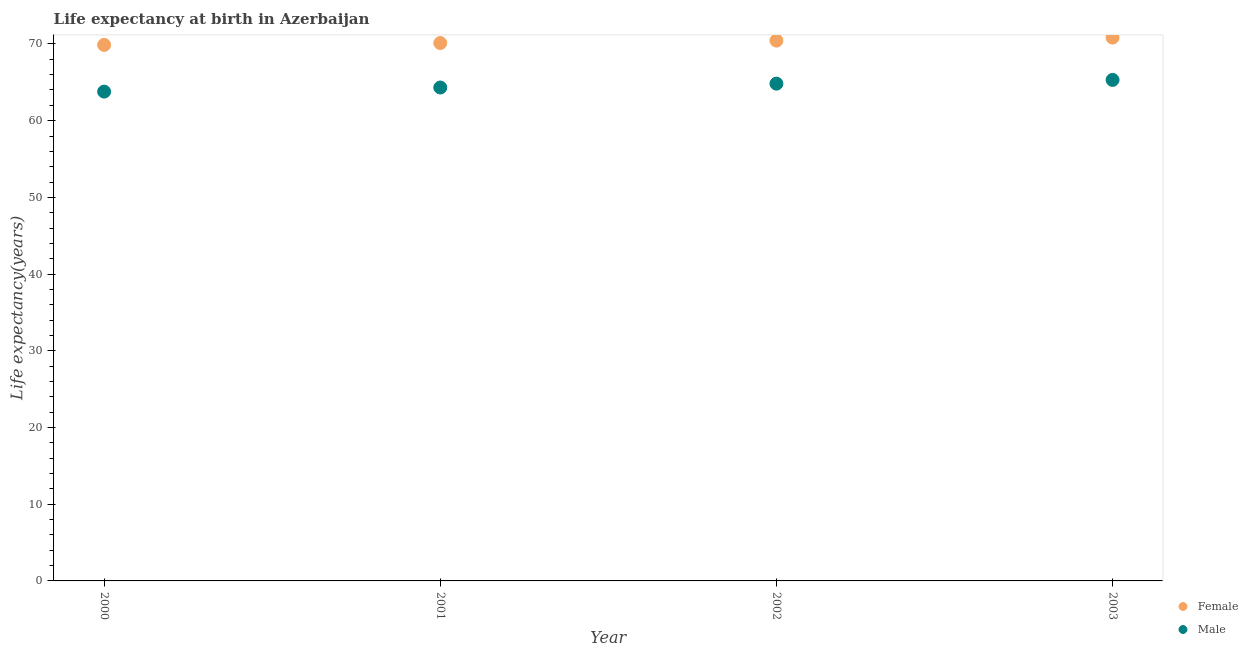What is the life expectancy(male) in 2001?
Ensure brevity in your answer.  64.32. Across all years, what is the maximum life expectancy(male)?
Provide a short and direct response. 65.31. Across all years, what is the minimum life expectancy(female)?
Offer a terse response. 69.88. In which year was the life expectancy(male) minimum?
Your response must be concise. 2000. What is the total life expectancy(female) in the graph?
Offer a terse response. 281.26. What is the difference between the life expectancy(female) in 2002 and that in 2003?
Keep it short and to the point. -0.4. What is the difference between the life expectancy(female) in 2003 and the life expectancy(male) in 2000?
Your answer should be compact. 7.04. What is the average life expectancy(female) per year?
Provide a succinct answer. 70.32. In the year 2003, what is the difference between the life expectancy(male) and life expectancy(female)?
Provide a succinct answer. -5.52. What is the ratio of the life expectancy(female) in 2001 to that in 2002?
Make the answer very short. 1. Is the difference between the life expectancy(female) in 2001 and 2002 greater than the difference between the life expectancy(male) in 2001 and 2002?
Make the answer very short. Yes. What is the difference between the highest and the second highest life expectancy(female)?
Provide a succinct answer. 0.4. What is the difference between the highest and the lowest life expectancy(male)?
Offer a terse response. 1.52. Is the sum of the life expectancy(female) in 2000 and 2002 greater than the maximum life expectancy(male) across all years?
Make the answer very short. Yes. Does the life expectancy(male) monotonically increase over the years?
Your response must be concise. Yes. How many dotlines are there?
Make the answer very short. 2. How many years are there in the graph?
Offer a terse response. 4. What is the difference between two consecutive major ticks on the Y-axis?
Your answer should be very brief. 10. Are the values on the major ticks of Y-axis written in scientific E-notation?
Provide a short and direct response. No. Does the graph contain grids?
Your response must be concise. No. Where does the legend appear in the graph?
Make the answer very short. Bottom right. How many legend labels are there?
Offer a terse response. 2. How are the legend labels stacked?
Make the answer very short. Vertical. What is the title of the graph?
Your response must be concise. Life expectancy at birth in Azerbaijan. What is the label or title of the Y-axis?
Give a very brief answer. Life expectancy(years). What is the Life expectancy(years) of Female in 2000?
Your answer should be compact. 69.88. What is the Life expectancy(years) in Male in 2000?
Keep it short and to the point. 63.79. What is the Life expectancy(years) of Female in 2001?
Offer a terse response. 70.12. What is the Life expectancy(years) in Male in 2001?
Your response must be concise. 64.32. What is the Life expectancy(years) in Female in 2002?
Your answer should be very brief. 70.44. What is the Life expectancy(years) in Male in 2002?
Give a very brief answer. 64.82. What is the Life expectancy(years) of Female in 2003?
Offer a very short reply. 70.83. What is the Life expectancy(years) of Male in 2003?
Offer a terse response. 65.31. Across all years, what is the maximum Life expectancy(years) in Female?
Your answer should be compact. 70.83. Across all years, what is the maximum Life expectancy(years) in Male?
Your answer should be very brief. 65.31. Across all years, what is the minimum Life expectancy(years) in Female?
Offer a very short reply. 69.88. Across all years, what is the minimum Life expectancy(years) in Male?
Give a very brief answer. 63.79. What is the total Life expectancy(years) of Female in the graph?
Your answer should be very brief. 281.26. What is the total Life expectancy(years) of Male in the graph?
Make the answer very short. 258.25. What is the difference between the Life expectancy(years) of Female in 2000 and that in 2001?
Offer a terse response. -0.24. What is the difference between the Life expectancy(years) in Male in 2000 and that in 2001?
Offer a terse response. -0.53. What is the difference between the Life expectancy(years) of Female in 2000 and that in 2002?
Your answer should be very brief. -0.56. What is the difference between the Life expectancy(years) of Male in 2000 and that in 2002?
Your answer should be compact. -1.04. What is the difference between the Life expectancy(years) in Female in 2000 and that in 2003?
Give a very brief answer. -0.95. What is the difference between the Life expectancy(years) of Male in 2000 and that in 2003?
Your answer should be very brief. -1.52. What is the difference between the Life expectancy(years) in Female in 2001 and that in 2002?
Ensure brevity in your answer.  -0.32. What is the difference between the Life expectancy(years) of Male in 2001 and that in 2002?
Keep it short and to the point. -0.5. What is the difference between the Life expectancy(years) of Female in 2001 and that in 2003?
Give a very brief answer. -0.71. What is the difference between the Life expectancy(years) of Male in 2001 and that in 2003?
Make the answer very short. -0.99. What is the difference between the Life expectancy(years) in Female in 2002 and that in 2003?
Your answer should be very brief. -0.4. What is the difference between the Life expectancy(years) in Male in 2002 and that in 2003?
Make the answer very short. -0.49. What is the difference between the Life expectancy(years) of Female in 2000 and the Life expectancy(years) of Male in 2001?
Provide a succinct answer. 5.55. What is the difference between the Life expectancy(years) in Female in 2000 and the Life expectancy(years) in Male in 2002?
Your answer should be compact. 5.05. What is the difference between the Life expectancy(years) in Female in 2000 and the Life expectancy(years) in Male in 2003?
Give a very brief answer. 4.57. What is the difference between the Life expectancy(years) of Female in 2001 and the Life expectancy(years) of Male in 2002?
Offer a terse response. 5.3. What is the difference between the Life expectancy(years) of Female in 2001 and the Life expectancy(years) of Male in 2003?
Make the answer very short. 4.81. What is the difference between the Life expectancy(years) in Female in 2002 and the Life expectancy(years) in Male in 2003?
Your answer should be very brief. 5.12. What is the average Life expectancy(years) in Female per year?
Give a very brief answer. 70.32. What is the average Life expectancy(years) of Male per year?
Offer a very short reply. 64.56. In the year 2000, what is the difference between the Life expectancy(years) in Female and Life expectancy(years) in Male?
Give a very brief answer. 6.09. In the year 2001, what is the difference between the Life expectancy(years) in Female and Life expectancy(years) in Male?
Your answer should be very brief. 5.8. In the year 2002, what is the difference between the Life expectancy(years) in Female and Life expectancy(years) in Male?
Provide a succinct answer. 5.61. In the year 2003, what is the difference between the Life expectancy(years) of Female and Life expectancy(years) of Male?
Ensure brevity in your answer.  5.52. What is the ratio of the Life expectancy(years) of Male in 2000 to that in 2001?
Give a very brief answer. 0.99. What is the ratio of the Life expectancy(years) in Female in 2000 to that in 2002?
Offer a very short reply. 0.99. What is the ratio of the Life expectancy(years) of Male in 2000 to that in 2002?
Offer a terse response. 0.98. What is the ratio of the Life expectancy(years) in Female in 2000 to that in 2003?
Provide a short and direct response. 0.99. What is the ratio of the Life expectancy(years) of Male in 2000 to that in 2003?
Keep it short and to the point. 0.98. What is the ratio of the Life expectancy(years) in Female in 2001 to that in 2003?
Make the answer very short. 0.99. What is the ratio of the Life expectancy(years) in Male in 2001 to that in 2003?
Your answer should be very brief. 0.98. What is the ratio of the Life expectancy(years) in Female in 2002 to that in 2003?
Your answer should be compact. 0.99. What is the ratio of the Life expectancy(years) of Male in 2002 to that in 2003?
Keep it short and to the point. 0.99. What is the difference between the highest and the second highest Life expectancy(years) in Female?
Offer a very short reply. 0.4. What is the difference between the highest and the second highest Life expectancy(years) of Male?
Your answer should be very brief. 0.49. What is the difference between the highest and the lowest Life expectancy(years) in Female?
Make the answer very short. 0.95. What is the difference between the highest and the lowest Life expectancy(years) in Male?
Offer a terse response. 1.52. 